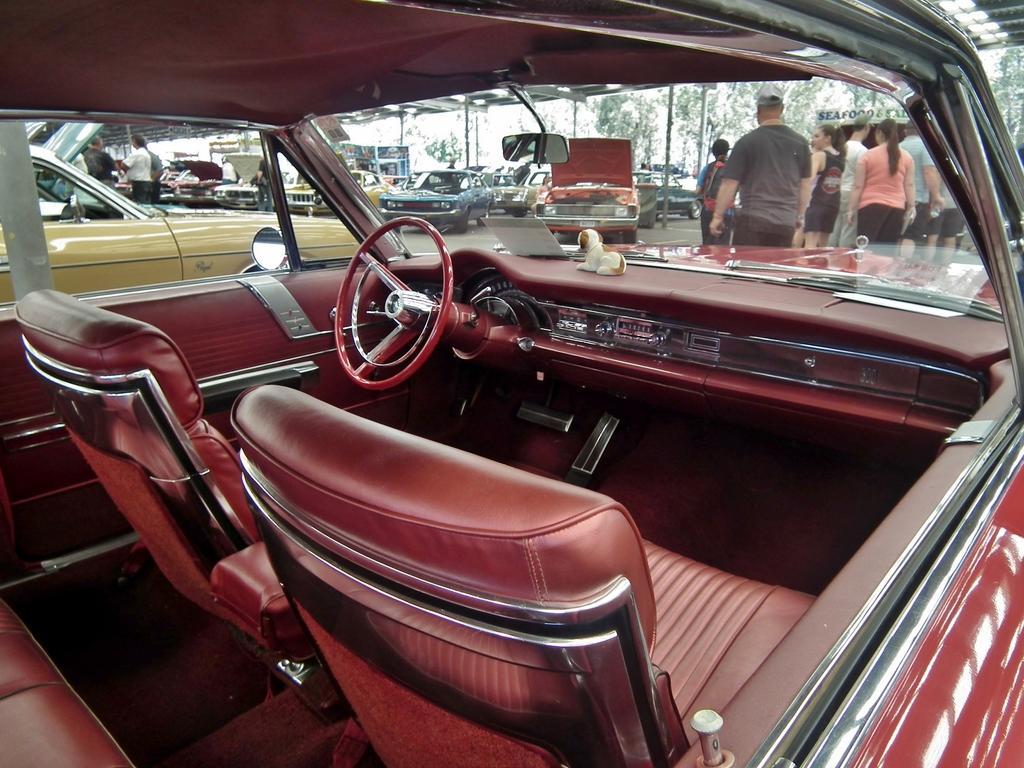In one or two sentences, can you explain what this image depicts? In the image in the center, we can see one brown color vehicle. In the vehicle, there is a steering wheel, mirror, toy, seats and a few other objects. In the background we can see buildings, trees, vehicles and a few people were standing. 